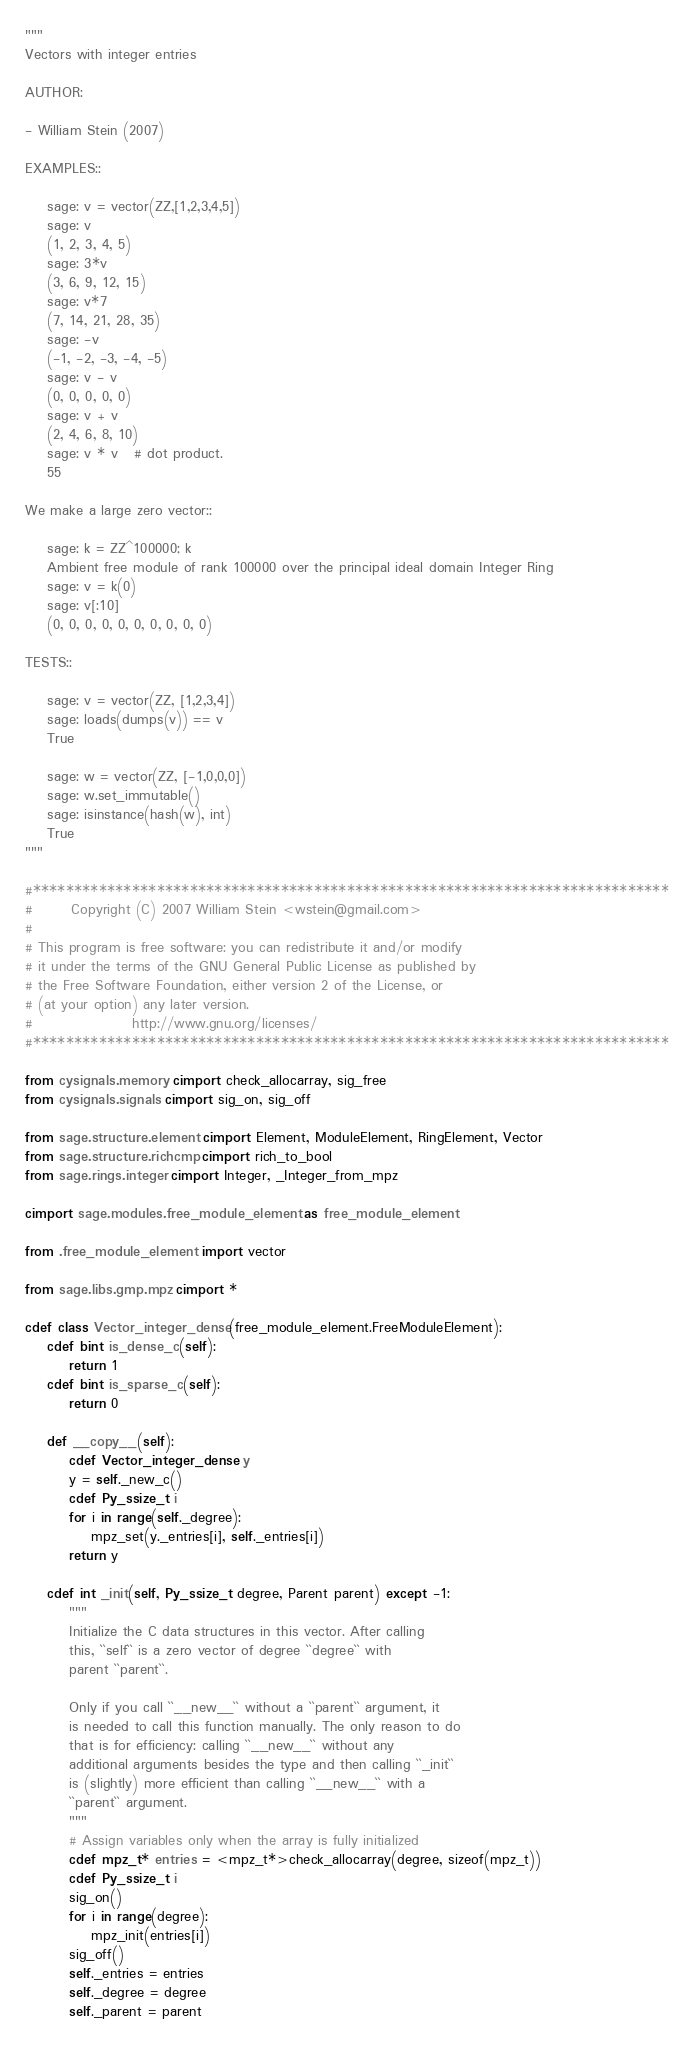Convert code to text. <code><loc_0><loc_0><loc_500><loc_500><_Cython_>"""
Vectors with integer entries

AUTHOR:

- William Stein (2007)

EXAMPLES::

    sage: v = vector(ZZ,[1,2,3,4,5])
    sage: v
    (1, 2, 3, 4, 5)
    sage: 3*v
    (3, 6, 9, 12, 15)
    sage: v*7
    (7, 14, 21, 28, 35)
    sage: -v
    (-1, -2, -3, -4, -5)
    sage: v - v
    (0, 0, 0, 0, 0)
    sage: v + v
    (2, 4, 6, 8, 10)
    sage: v * v   # dot product.
    55

We make a large zero vector::

    sage: k = ZZ^100000; k
    Ambient free module of rank 100000 over the principal ideal domain Integer Ring
    sage: v = k(0)
    sage: v[:10]
    (0, 0, 0, 0, 0, 0, 0, 0, 0, 0)

TESTS::

    sage: v = vector(ZZ, [1,2,3,4])
    sage: loads(dumps(v)) == v
    True

    sage: w = vector(ZZ, [-1,0,0,0])
    sage: w.set_immutable()
    sage: isinstance(hash(w), int)
    True
"""

#*****************************************************************************
#       Copyright (C) 2007 William Stein <wstein@gmail.com>
#
# This program is free software: you can redistribute it and/or modify
# it under the terms of the GNU General Public License as published by
# the Free Software Foundation, either version 2 of the License, or
# (at your option) any later version.
#                  http://www.gnu.org/licenses/
#*****************************************************************************

from cysignals.memory cimport check_allocarray, sig_free
from cysignals.signals cimport sig_on, sig_off

from sage.structure.element cimport Element, ModuleElement, RingElement, Vector
from sage.structure.richcmp cimport rich_to_bool
from sage.rings.integer cimport Integer, _Integer_from_mpz

cimport sage.modules.free_module_element as free_module_element

from .free_module_element import vector

from sage.libs.gmp.mpz cimport *

cdef class Vector_integer_dense(free_module_element.FreeModuleElement):
    cdef bint is_dense_c(self):
        return 1
    cdef bint is_sparse_c(self):
        return 0

    def __copy__(self):
        cdef Vector_integer_dense y
        y = self._new_c()
        cdef Py_ssize_t i
        for i in range(self._degree):
            mpz_set(y._entries[i], self._entries[i])
        return y

    cdef int _init(self, Py_ssize_t degree, Parent parent) except -1:
        """
        Initialize the C data structures in this vector. After calling
        this, ``self`` is a zero vector of degree ``degree`` with
        parent ``parent``.

        Only if you call ``__new__`` without a ``parent`` argument, it
        is needed to call this function manually. The only reason to do
        that is for efficiency: calling ``__new__`` without any
        additional arguments besides the type and then calling ``_init``
        is (slightly) more efficient than calling ``__new__`` with a
        ``parent`` argument.
        """
        # Assign variables only when the array is fully initialized
        cdef mpz_t* entries = <mpz_t*>check_allocarray(degree, sizeof(mpz_t))
        cdef Py_ssize_t i
        sig_on()
        for i in range(degree):
            mpz_init(entries[i])
        sig_off()
        self._entries = entries
        self._degree = degree
        self._parent = parent
</code> 